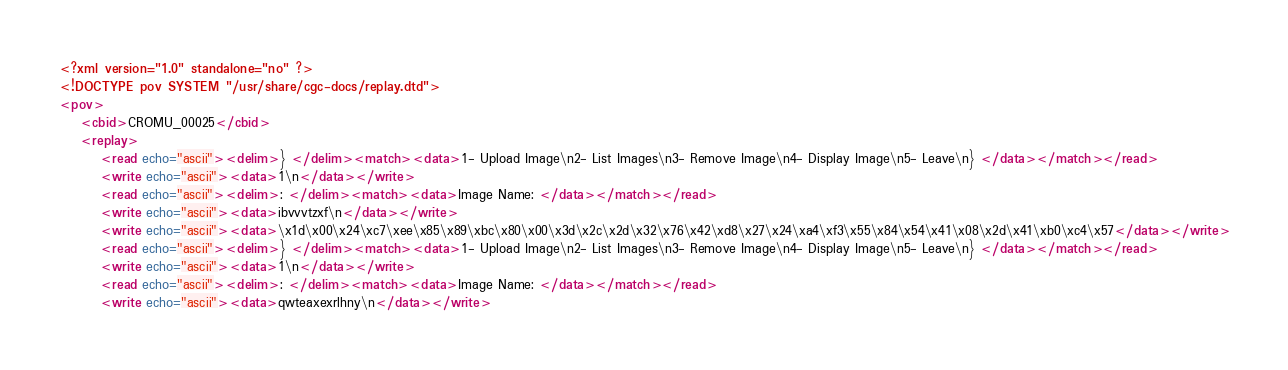Convert code to text. <code><loc_0><loc_0><loc_500><loc_500><_XML_><?xml version="1.0" standalone="no" ?>
<!DOCTYPE pov SYSTEM "/usr/share/cgc-docs/replay.dtd">
<pov>
	<cbid>CROMU_00025</cbid>
	<replay>
		<read echo="ascii"><delim>} </delim><match><data>1- Upload Image\n2- List Images\n3- Remove Image\n4- Display Image\n5- Leave\n} </data></match></read>
		<write echo="ascii"><data>1\n</data></write>
		<read echo="ascii"><delim>: </delim><match><data>Image Name: </data></match></read>
		<write echo="ascii"><data>ibvvvtzxf\n</data></write>
		<write echo="ascii"><data>\x1d\x00\x24\xc7\xee\x85\x89\xbc\x80\x00\x3d\x2c\x2d\x32\x76\x42\xd8\x27\x24\xa4\xf3\x55\x84\x54\x41\x08\x2d\x41\xb0\xc4\x57</data></write>
		<read echo="ascii"><delim>} </delim><match><data>1- Upload Image\n2- List Images\n3- Remove Image\n4- Display Image\n5- Leave\n} </data></match></read>
		<write echo="ascii"><data>1\n</data></write>
		<read echo="ascii"><delim>: </delim><match><data>Image Name: </data></match></read>
		<write echo="ascii"><data>qwteaxexrlhny\n</data></write></code> 